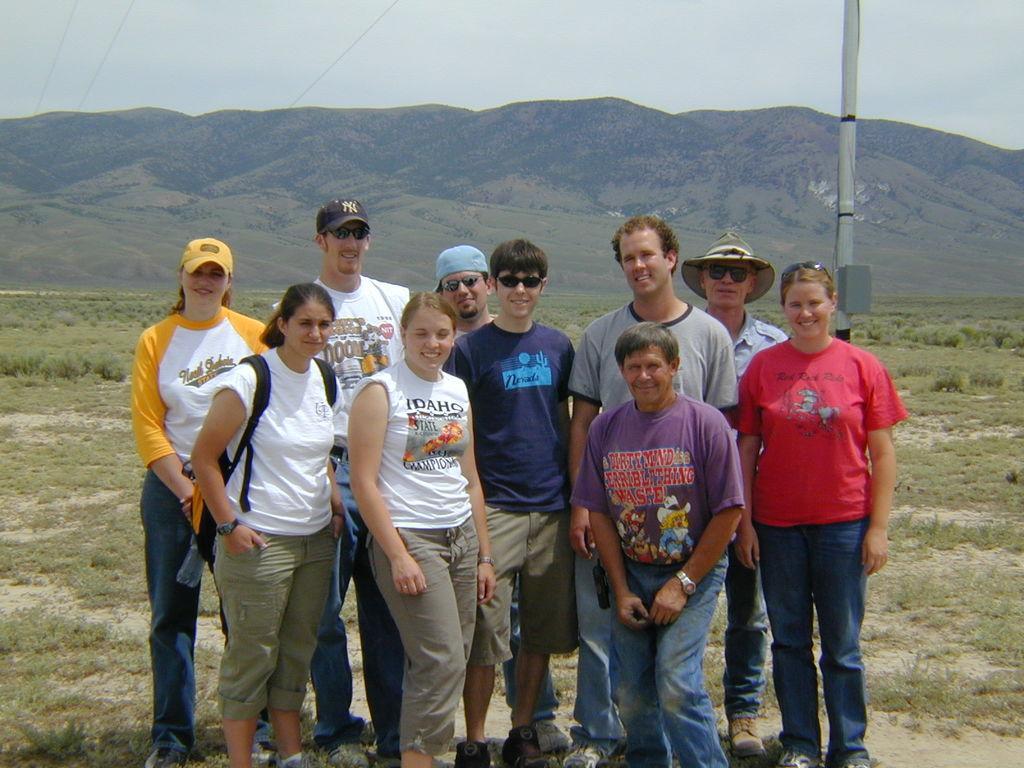Can you describe this image briefly? In this picture we can see a group of people smiling, standing on the ground and at the back them we can see the grass, pole, mountains and in the background we can see the sky. 